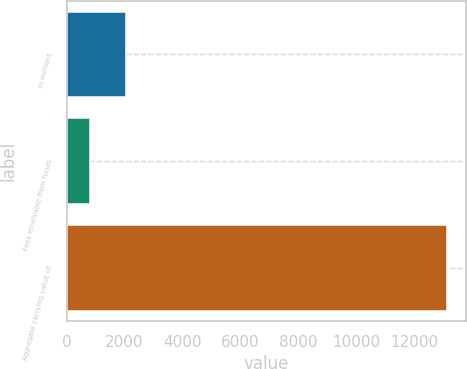Convert chart to OTSL. <chart><loc_0><loc_0><loc_500><loc_500><bar_chart><fcel>in millions<fcel>Fees receivable from funds<fcel>Aggregate carrying value of<nl><fcel>2047.7<fcel>817<fcel>13124<nl></chart> 